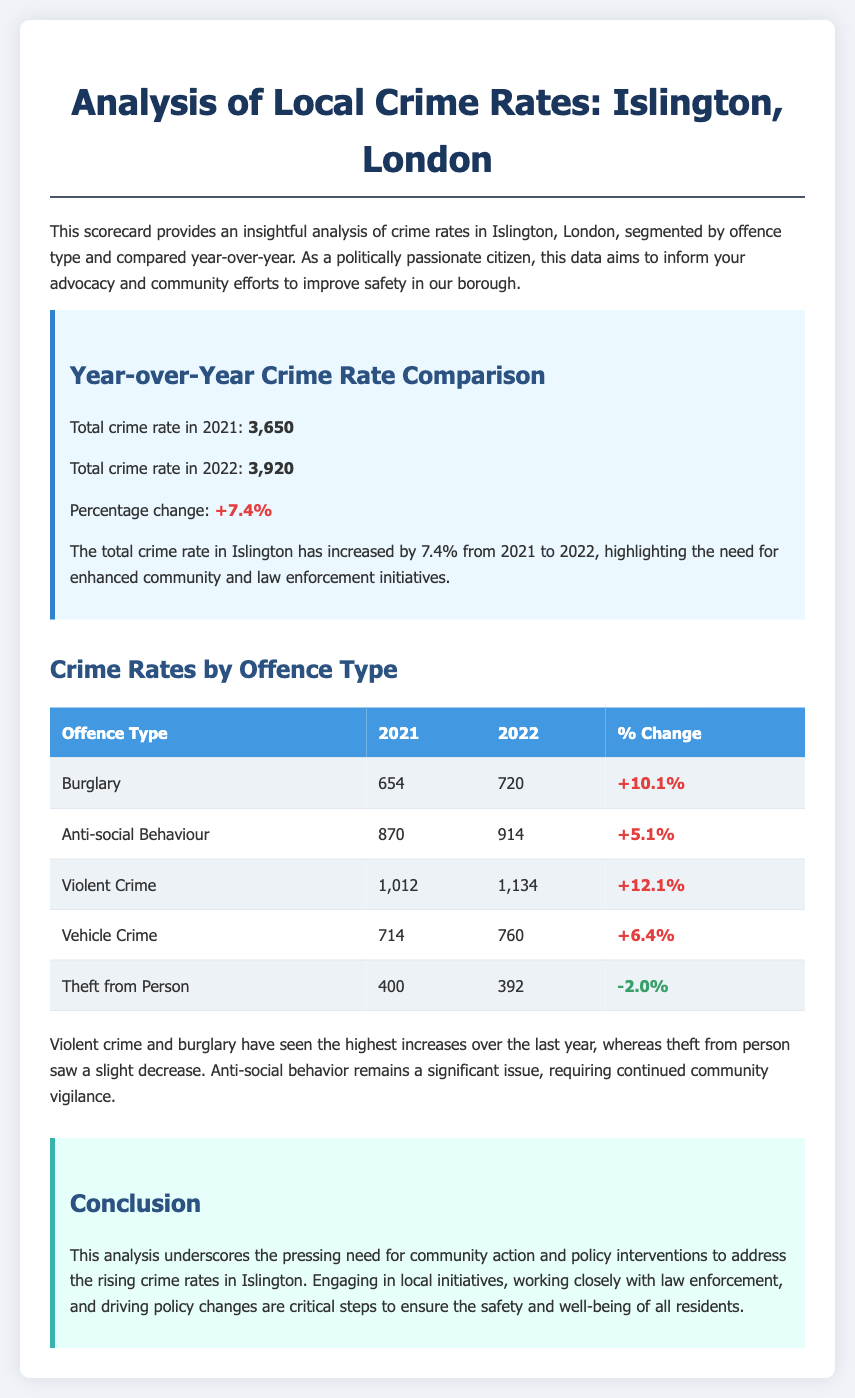what was the total crime rate in 2021? The total crime rate for the year 2021 is explicitly stated in the document as 3,650.
Answer: 3,650 what was the percentage change in violent crime from 2021 to 2022? The percentage change for violent crime from 2021 to 2022 is found in the crime rates by offence type section of the document.
Answer: +12.1% how many anti-social behaviour incidents were reported in 2022? The number of anti-social behaviour incidents in 2022 is listed in the table under crime rates by offence type.
Answer: 914 which offence type saw a decrease in occurrences from 2021 to 2022? The document indicates the offence types and their changes, pinpointing which ones decreased in the specified timeframe.
Answer: Theft from Person what key issue requires continued community vigilance according to the document? The conclusion provides insights on ongoing issues that need attention and advocacy from citizens.
Answer: Anti-social behaviour what is the main conclusion of the analysis? The conclusion section summarizes the overall findings and the need for action; it points to the outcomes discussed earlier in the document.
Answer: Need for community action and policy interventions how many vehicle crimes were reported in 2021? The number of vehicle crimes for 2021 can be directly retrieved from the crime rates by offence type table.
Answer: 714 what colour represents an increase in percentage change in the document? The document uses specific colours to represent changes in crime rates visually; this specific colour is clearly denoted in the styling sections.
Answer: Red 